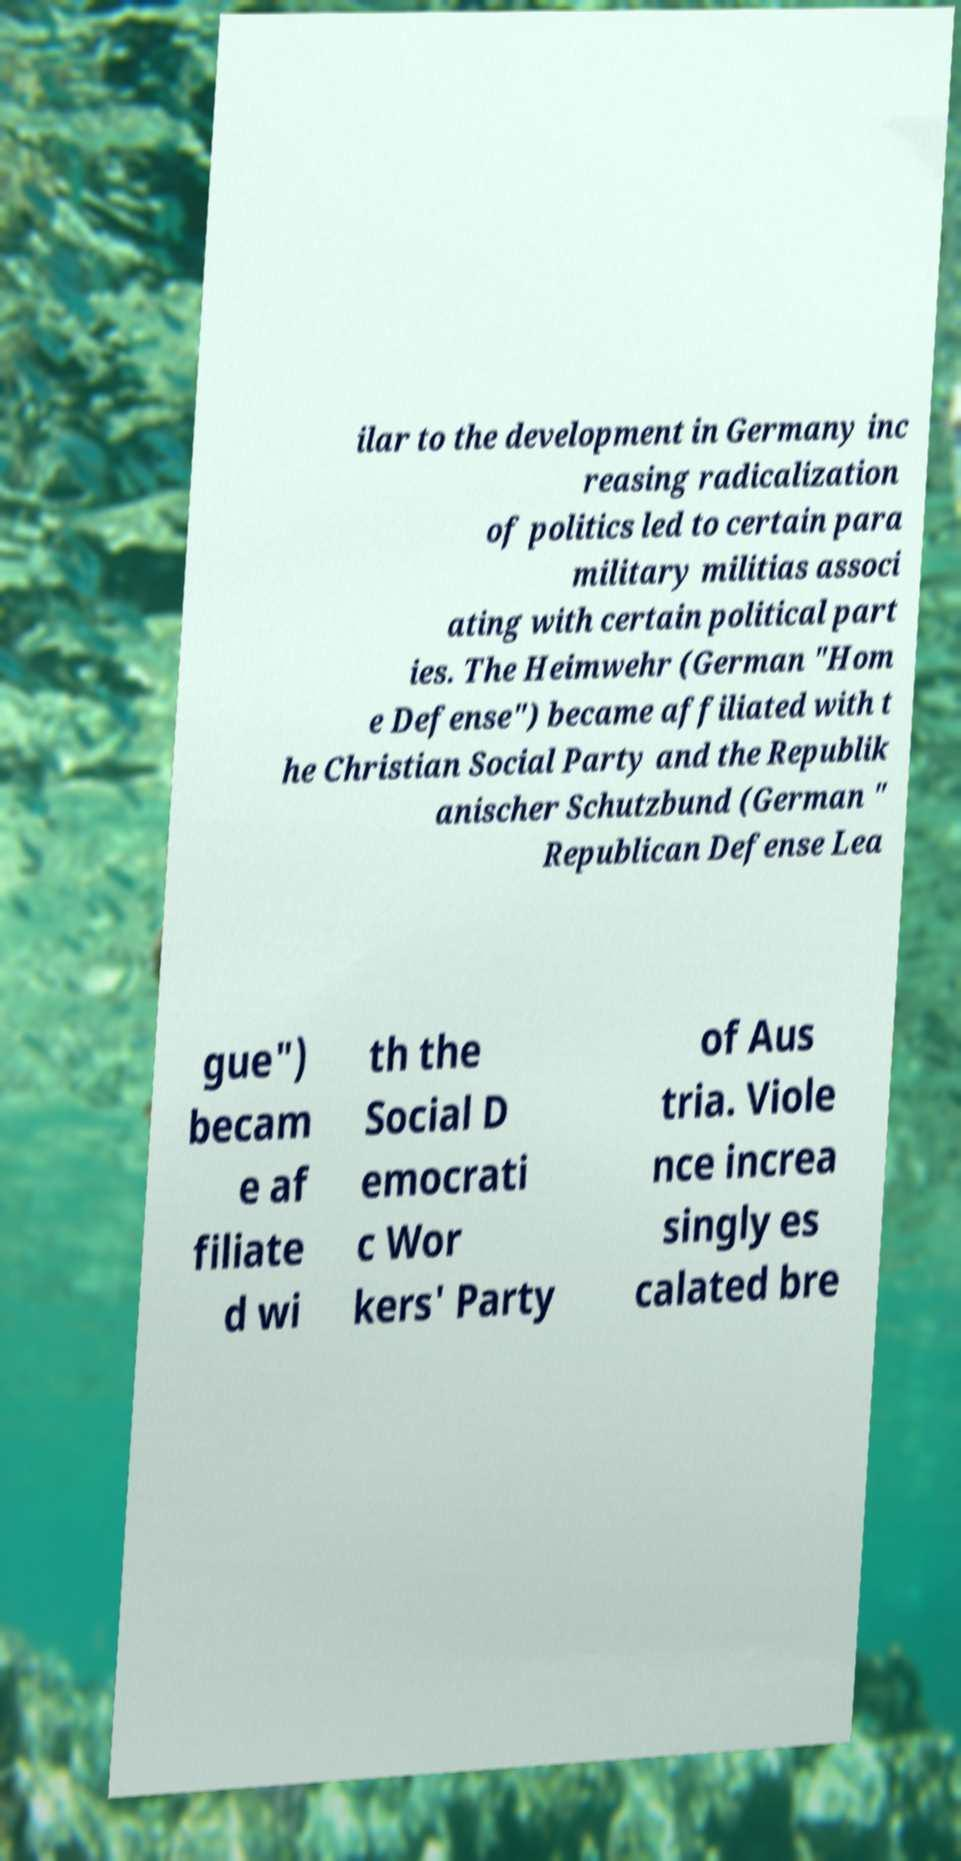Can you read and provide the text displayed in the image?This photo seems to have some interesting text. Can you extract and type it out for me? ilar to the development in Germany inc reasing radicalization of politics led to certain para military militias associ ating with certain political part ies. The Heimwehr (German "Hom e Defense") became affiliated with t he Christian Social Party and the Republik anischer Schutzbund (German " Republican Defense Lea gue") becam e af filiate d wi th the Social D emocrati c Wor kers' Party of Aus tria. Viole nce increa singly es calated bre 